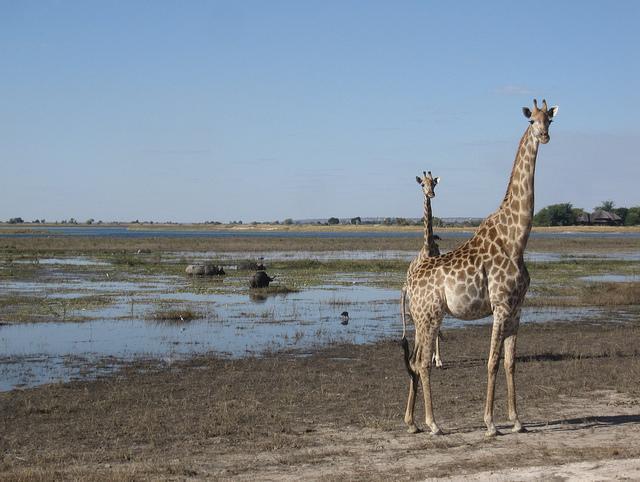The giraffe in the front is probably related to the one behind in what way?
Choose the correct response and explain in the format: 'Answer: answer
Rationale: rationale.'
Options: Sibling, parent, partner, none. Answer: parent.
Rationale: It is much larger than the small one 